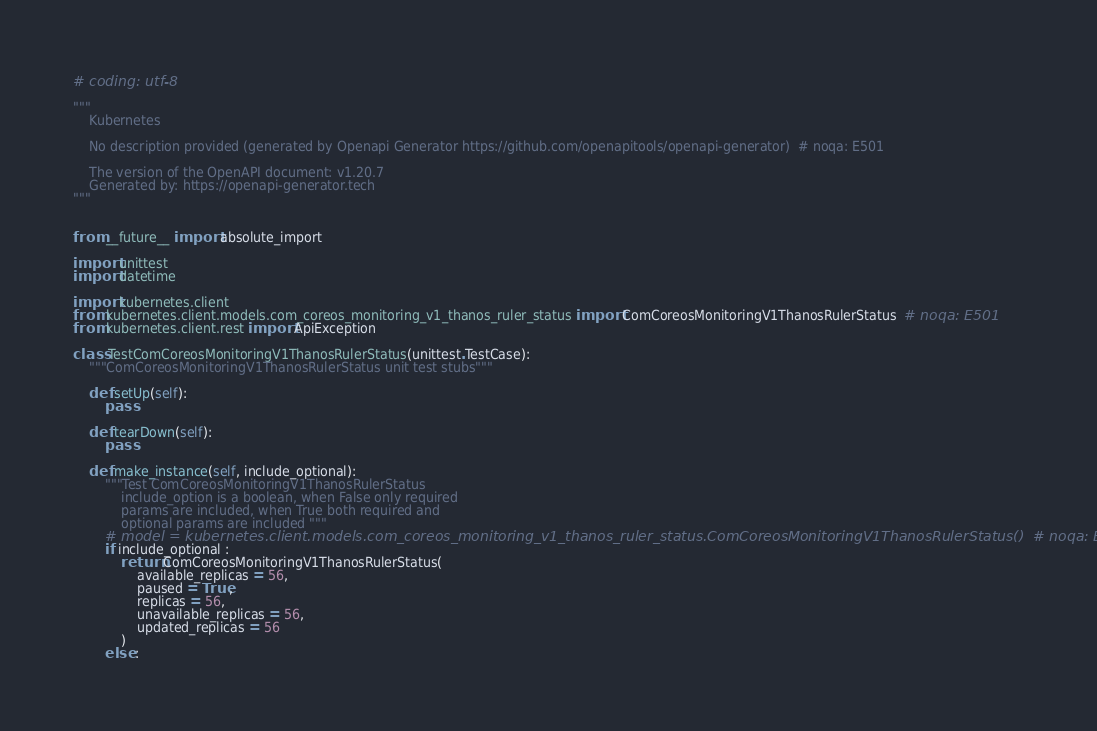Convert code to text. <code><loc_0><loc_0><loc_500><loc_500><_Python_># coding: utf-8

"""
    Kubernetes

    No description provided (generated by Openapi Generator https://github.com/openapitools/openapi-generator)  # noqa: E501

    The version of the OpenAPI document: v1.20.7
    Generated by: https://openapi-generator.tech
"""


from __future__ import absolute_import

import unittest
import datetime

import kubernetes.client
from kubernetes.client.models.com_coreos_monitoring_v1_thanos_ruler_status import ComCoreosMonitoringV1ThanosRulerStatus  # noqa: E501
from kubernetes.client.rest import ApiException

class TestComCoreosMonitoringV1ThanosRulerStatus(unittest.TestCase):
    """ComCoreosMonitoringV1ThanosRulerStatus unit test stubs"""

    def setUp(self):
        pass

    def tearDown(self):
        pass

    def make_instance(self, include_optional):
        """Test ComCoreosMonitoringV1ThanosRulerStatus
            include_option is a boolean, when False only required
            params are included, when True both required and
            optional params are included """
        # model = kubernetes.client.models.com_coreos_monitoring_v1_thanos_ruler_status.ComCoreosMonitoringV1ThanosRulerStatus()  # noqa: E501
        if include_optional :
            return ComCoreosMonitoringV1ThanosRulerStatus(
                available_replicas = 56, 
                paused = True, 
                replicas = 56, 
                unavailable_replicas = 56, 
                updated_replicas = 56
            )
        else :</code> 